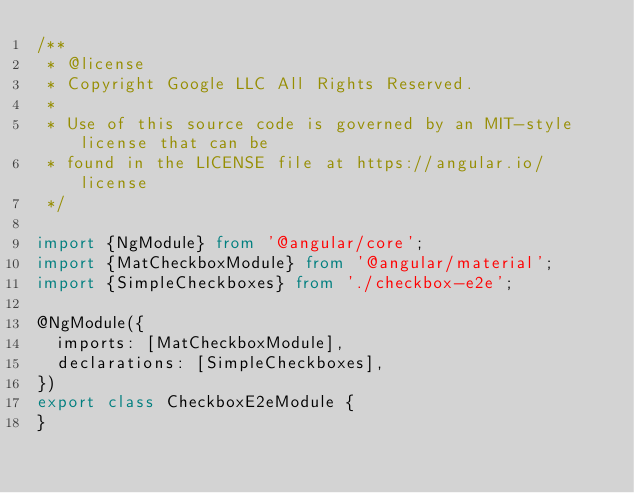Convert code to text. <code><loc_0><loc_0><loc_500><loc_500><_TypeScript_>/**
 * @license
 * Copyright Google LLC All Rights Reserved.
 *
 * Use of this source code is governed by an MIT-style license that can be
 * found in the LICENSE file at https://angular.io/license
 */

import {NgModule} from '@angular/core';
import {MatCheckboxModule} from '@angular/material';
import {SimpleCheckboxes} from './checkbox-e2e';

@NgModule({
  imports: [MatCheckboxModule],
  declarations: [SimpleCheckboxes],
})
export class CheckboxE2eModule {
}
</code> 